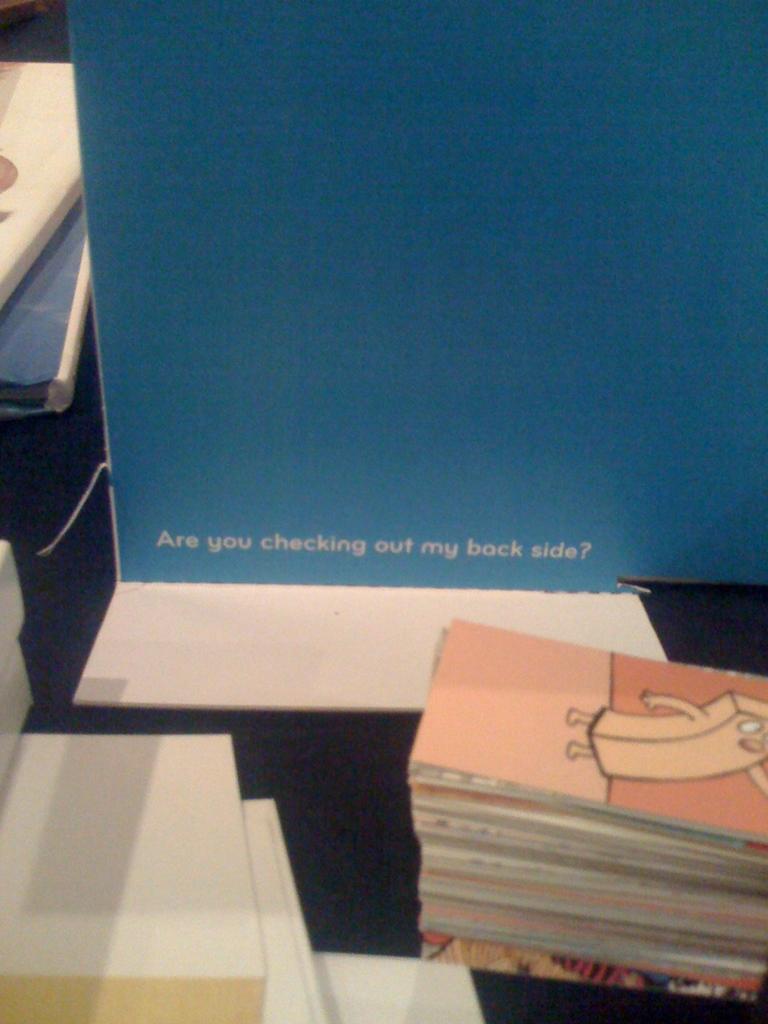What side does the book ask if we are checking out?
Ensure brevity in your answer.  Back side. 